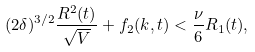<formula> <loc_0><loc_0><loc_500><loc_500>( 2 \delta ) ^ { 3 / 2 } \frac { R ^ { 2 } ( t ) } { \sqrt { V } } + f _ { 2 } ( k , t ) < \frac { \nu } { 6 } R _ { 1 } ( t ) ,</formula> 